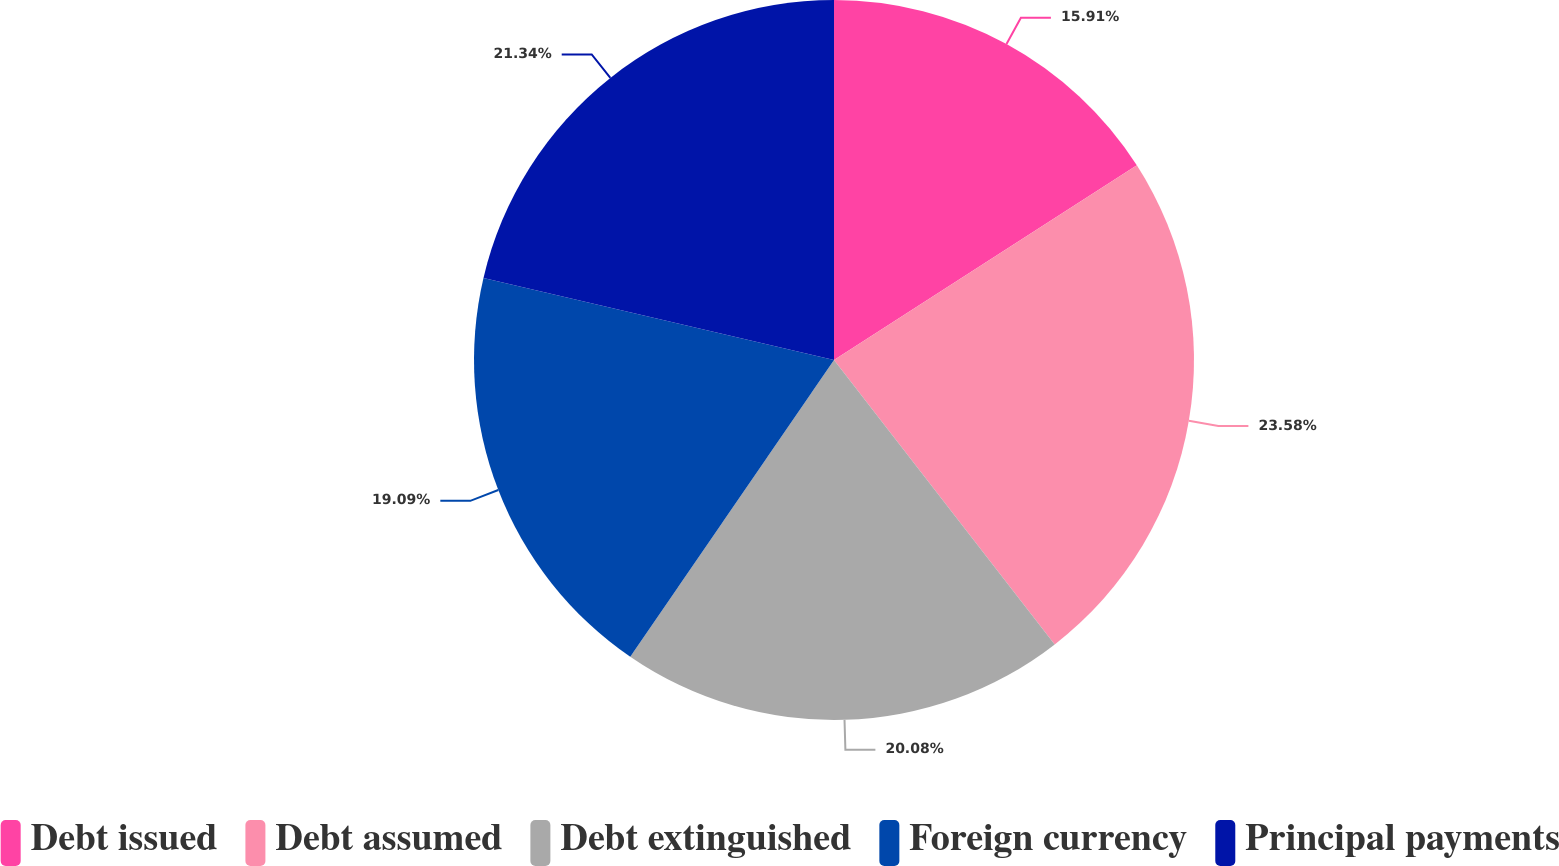Convert chart. <chart><loc_0><loc_0><loc_500><loc_500><pie_chart><fcel>Debt issued<fcel>Debt assumed<fcel>Debt extinguished<fcel>Foreign currency<fcel>Principal payments<nl><fcel>15.91%<fcel>23.59%<fcel>20.08%<fcel>19.09%<fcel>21.34%<nl></chart> 